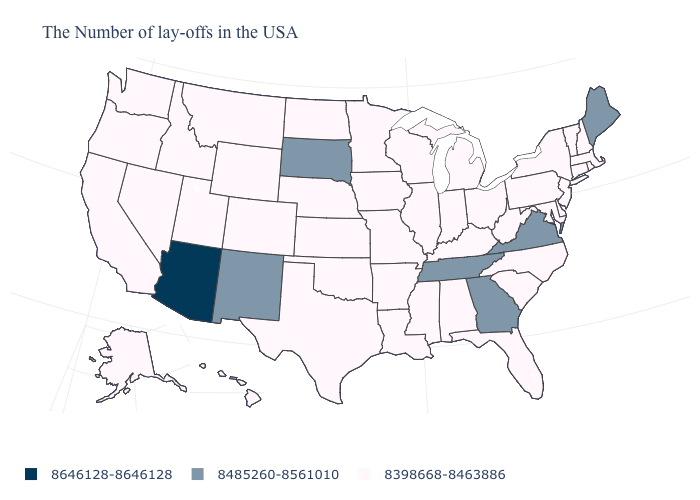Name the states that have a value in the range 8398668-8463886?
Concise answer only. Massachusetts, Rhode Island, New Hampshire, Vermont, Connecticut, New York, New Jersey, Delaware, Maryland, Pennsylvania, North Carolina, South Carolina, West Virginia, Ohio, Florida, Michigan, Kentucky, Indiana, Alabama, Wisconsin, Illinois, Mississippi, Louisiana, Missouri, Arkansas, Minnesota, Iowa, Kansas, Nebraska, Oklahoma, Texas, North Dakota, Wyoming, Colorado, Utah, Montana, Idaho, Nevada, California, Washington, Oregon, Alaska, Hawaii. What is the value of New Jersey?
Concise answer only. 8398668-8463886. Name the states that have a value in the range 8646128-8646128?
Be succinct. Arizona. What is the highest value in the USA?
Short answer required. 8646128-8646128. What is the value of Georgia?
Be succinct. 8485260-8561010. Does the map have missing data?
Write a very short answer. No. What is the value of Nebraska?
Be succinct. 8398668-8463886. Among the states that border Alabama , which have the highest value?
Answer briefly. Georgia, Tennessee. Which states hav the highest value in the West?
Short answer required. Arizona. What is the lowest value in the Northeast?
Keep it brief. 8398668-8463886. What is the value of North Carolina?
Give a very brief answer. 8398668-8463886. What is the value of North Carolina?
Write a very short answer. 8398668-8463886. Does Montana have the lowest value in the West?
Answer briefly. Yes. Which states have the lowest value in the West?
Quick response, please. Wyoming, Colorado, Utah, Montana, Idaho, Nevada, California, Washington, Oregon, Alaska, Hawaii. Does Idaho have the lowest value in the West?
Short answer required. Yes. 